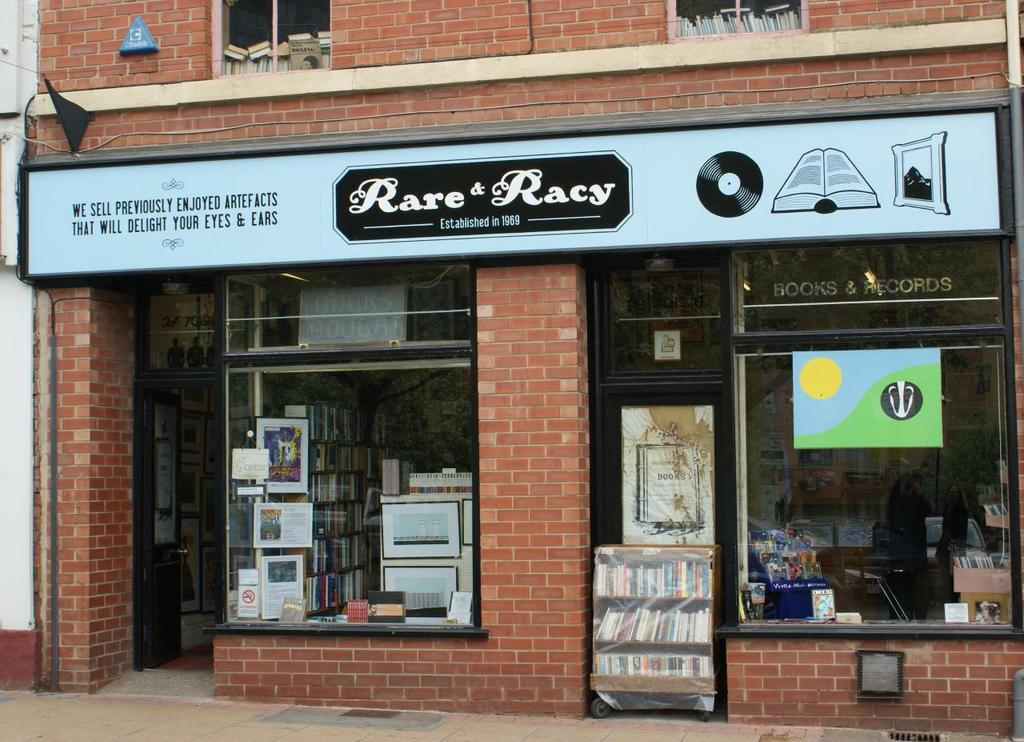<image>
Share a concise interpretation of the image provided. A signboard depicting the store name of Rare & Racy. 